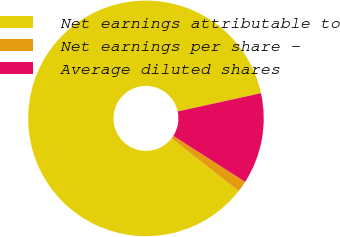<chart> <loc_0><loc_0><loc_500><loc_500><pie_chart><fcel>Net earnings attributable to<fcel>Net earnings per share -<fcel>Average diluted shares<nl><fcel>85.99%<fcel>1.52%<fcel>12.49%<nl></chart> 